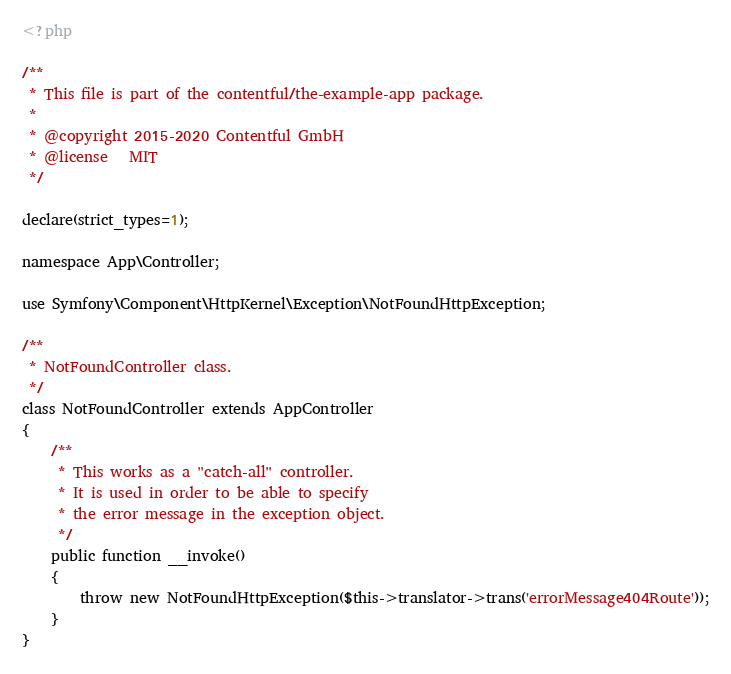<code> <loc_0><loc_0><loc_500><loc_500><_PHP_><?php

/**
 * This file is part of the contentful/the-example-app package.
 *
 * @copyright 2015-2020 Contentful GmbH
 * @license   MIT
 */

declare(strict_types=1);

namespace App\Controller;

use Symfony\Component\HttpKernel\Exception\NotFoundHttpException;

/**
 * NotFoundController class.
 */
class NotFoundController extends AppController
{
    /**
     * This works as a "catch-all" controller.
     * It is used in order to be able to specify
     * the error message in the exception object.
     */
    public function __invoke()
    {
        throw new NotFoundHttpException($this->translator->trans('errorMessage404Route'));
    }
}
</code> 